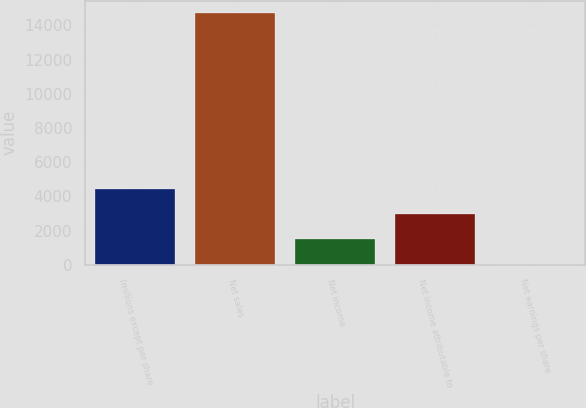<chart> <loc_0><loc_0><loc_500><loc_500><bar_chart><fcel>(millions except per share<fcel>Net sales<fcel>Net income<fcel>Net income attributable to<fcel>Net earnings per share<nl><fcel>4418.42<fcel>14722<fcel>1474.54<fcel>2946.48<fcel>2.6<nl></chart> 